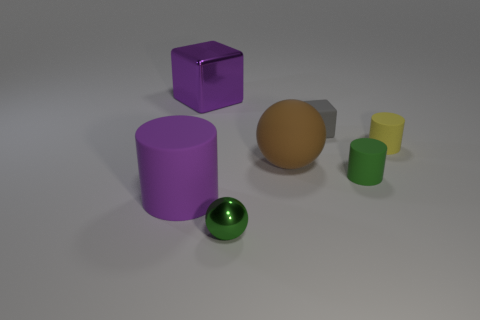How do the sizes of the objects compare to each other? The objects vary in size from small to large, with the yellow and green cylinders being the smallest, followed by the green sphere, the tan-colored hemisphere, the large sphere, and finally the purple cylinder as the largest object in view. 